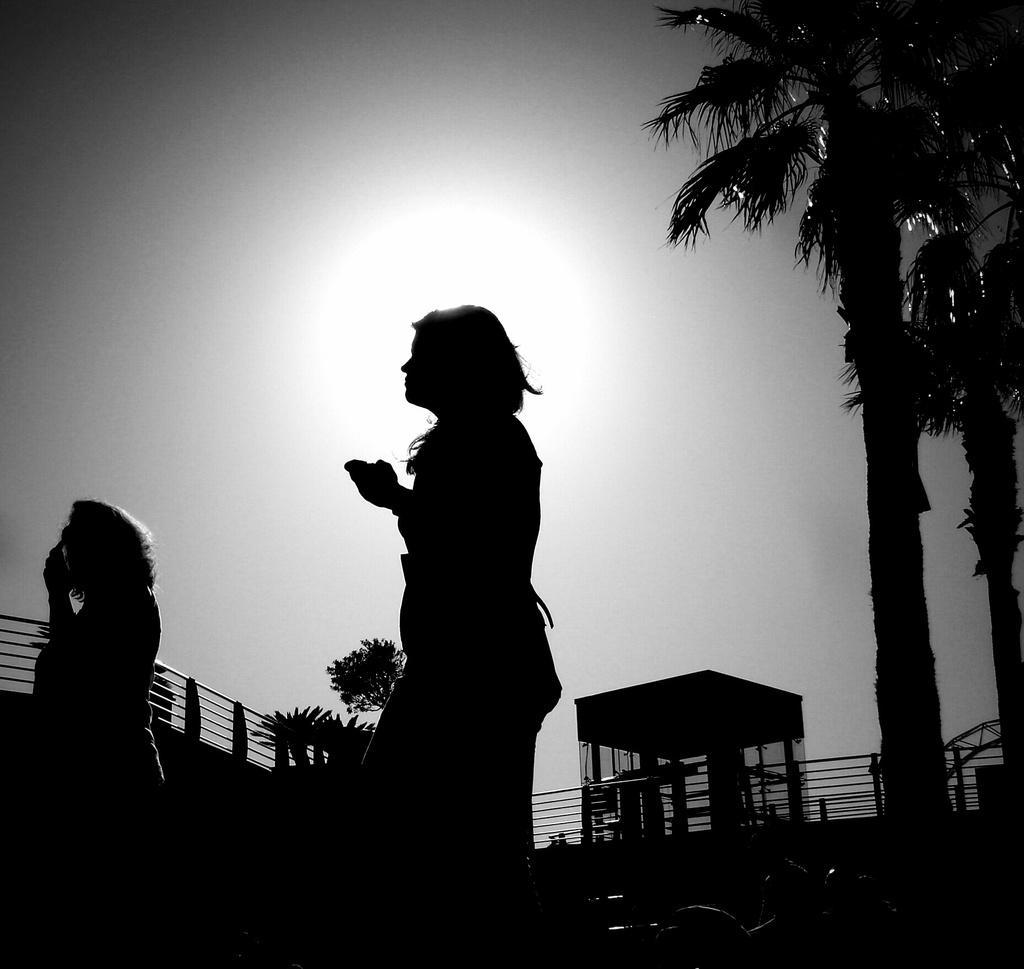Describe this image in one or two sentences. This is a dark image, we can see two persons, at the right side there are some trees, at the top there is a sky. 